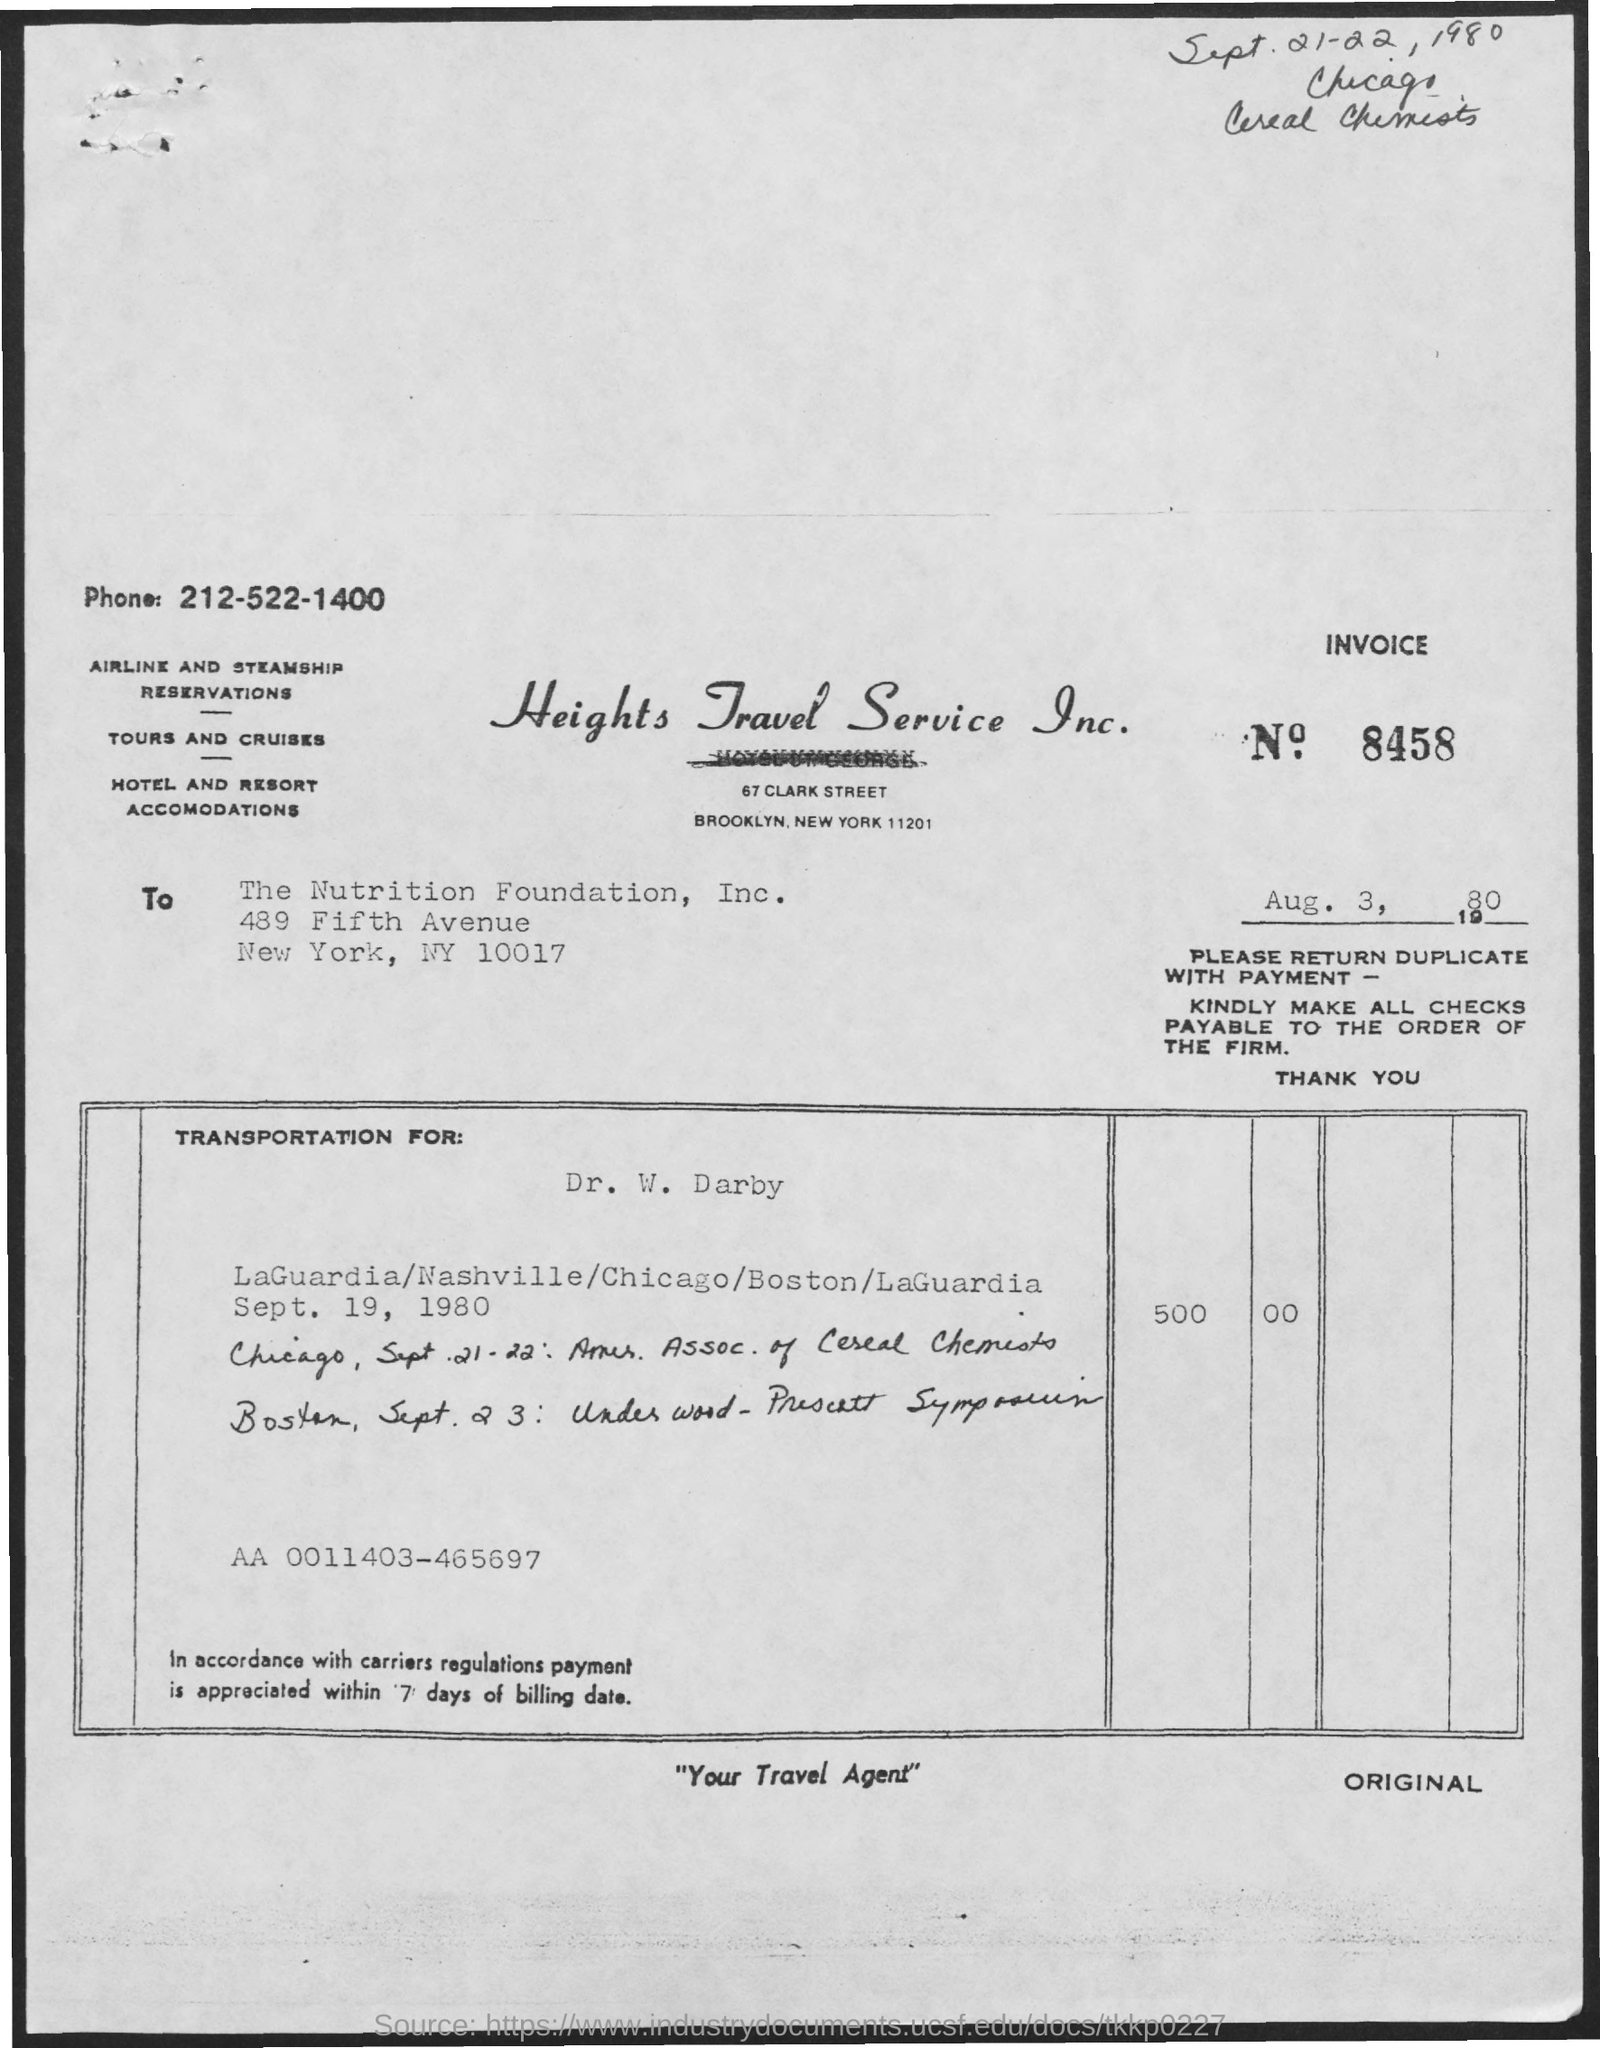List a handful of essential elements in this visual. The title of the document is Heights Travel Service Inc... The date mentioned below the invoice number is August 3, 1980. The phone number mentioned in the document is 212-522-1400. The invoice number is 8458. 